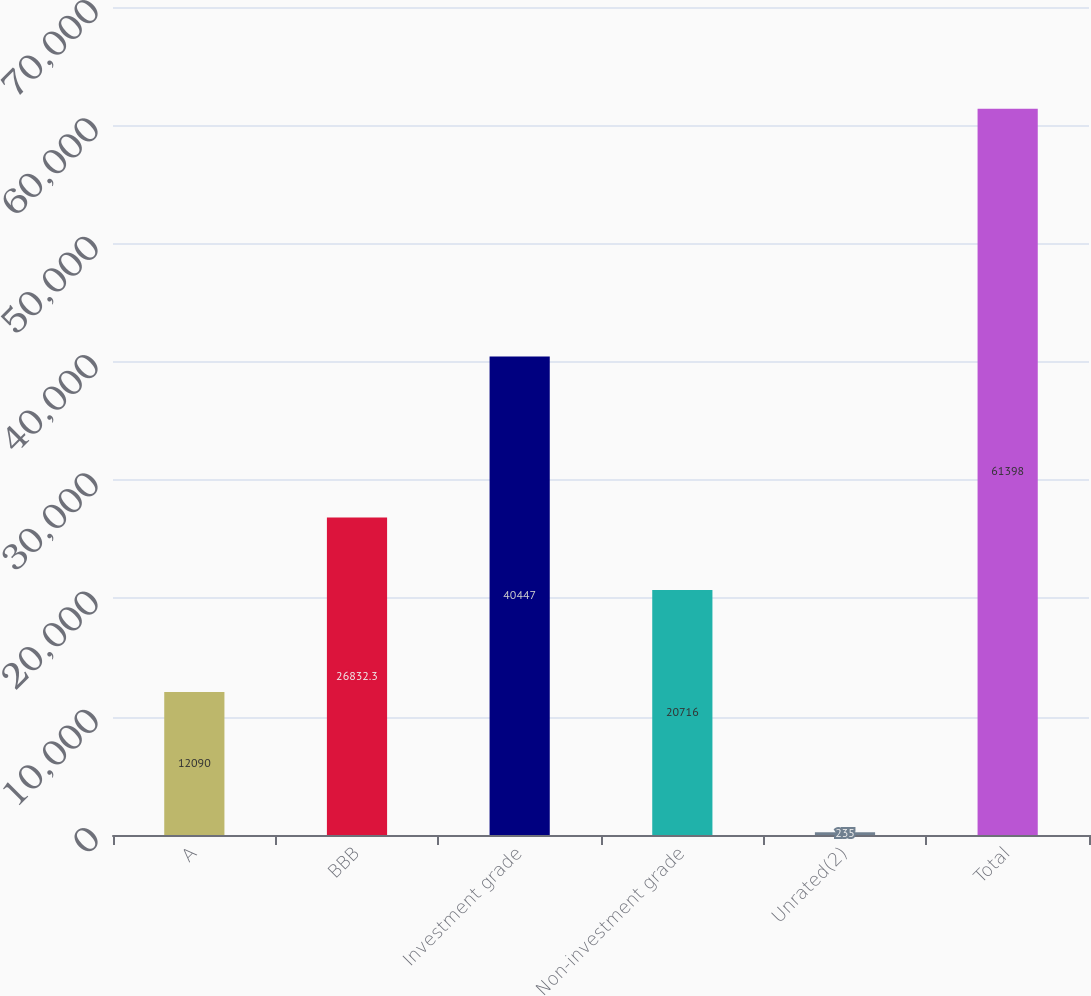Convert chart. <chart><loc_0><loc_0><loc_500><loc_500><bar_chart><fcel>A<fcel>BBB<fcel>Investment grade<fcel>Non-investment grade<fcel>Unrated(2)<fcel>Total<nl><fcel>12090<fcel>26832.3<fcel>40447<fcel>20716<fcel>235<fcel>61398<nl></chart> 